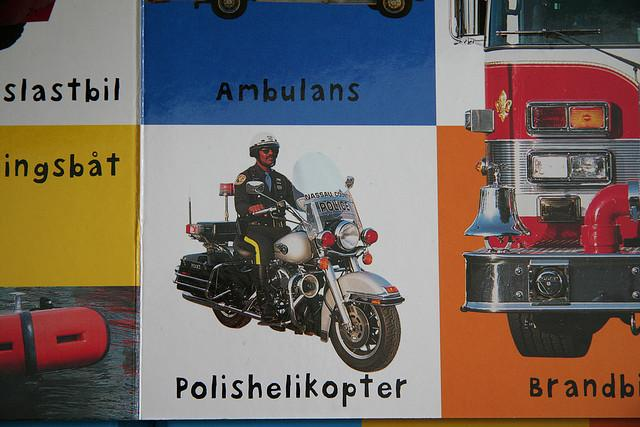What is the profession of the man on a motorcycle?

Choices:
A) athlete
B) fireman
C) officer
D) lifeguard officer 